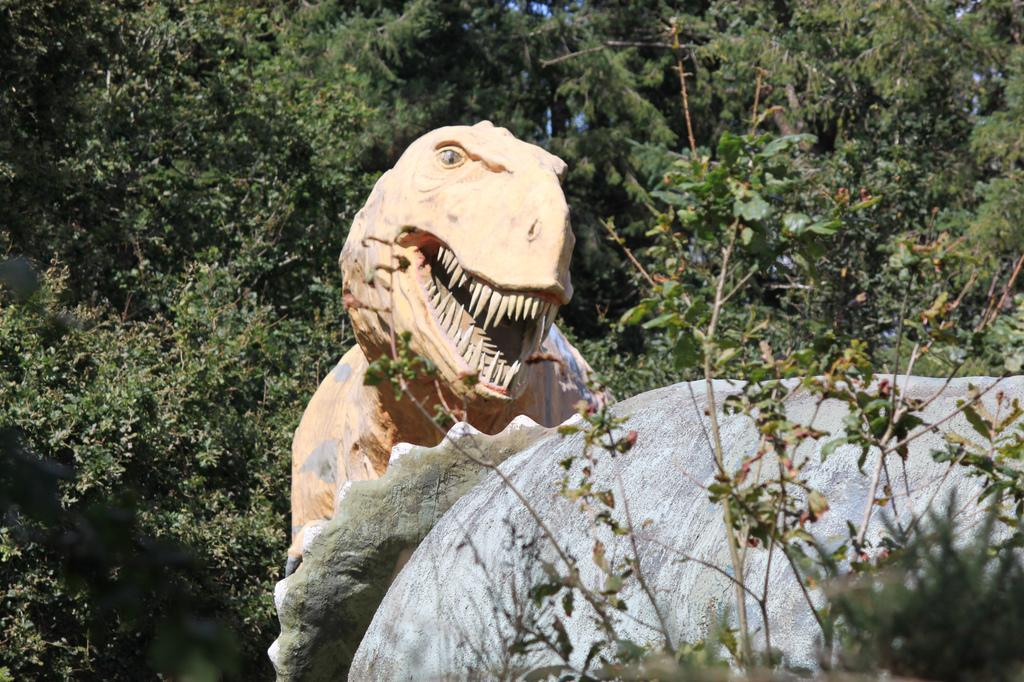What type of setting is depicted in the image? The image is an outside view. What is the main subject in the image? There is a statue of a dinosaur in the image. What is located in front of the dinosaur statue? There is a rock in front of the dinosaur statue. What can be seen in the distance in the image? There are trees visible in the background of the image. Where is the stove located in the image? There is no stove present in the image. What type of bottle can be seen near the dinosaur statue? There is no bottle present in the image. 